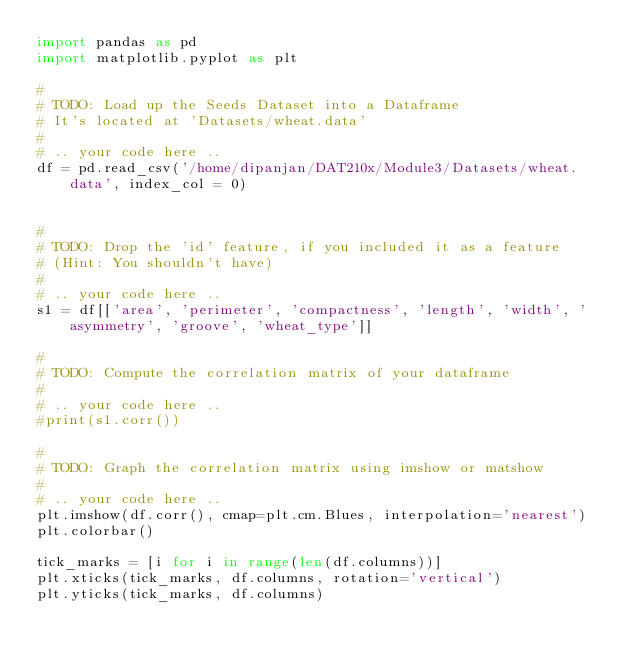<code> <loc_0><loc_0><loc_500><loc_500><_Python_>import pandas as pd
import matplotlib.pyplot as plt

#
# TODO: Load up the Seeds Dataset into a Dataframe
# It's located at 'Datasets/wheat.data'
# 
# .. your code here ..
df = pd.read_csv('/home/dipanjan/DAT210x/Module3/Datasets/wheat.data', index_col = 0)


#
# TODO: Drop the 'id' feature, if you included it as a feature
# (Hint: You shouldn't have)
# 
# .. your code here ..
s1 = df[['area', 'perimeter', 'compactness', 'length', 'width', 'asymmetry', 'groove', 'wheat_type']]

#
# TODO: Compute the correlation matrix of your dataframe
# 
# .. your code here ..
#print(s1.corr())

#
# TODO: Graph the correlation matrix using imshow or matshow
# 
# .. your code here ..
plt.imshow(df.corr(), cmap=plt.cm.Blues, interpolation='nearest')
plt.colorbar()

tick_marks = [i for i in range(len(df.columns))]
plt.xticks(tick_marks, df.columns, rotation='vertical')
plt.yticks(tick_marks, df.columns)


</code> 